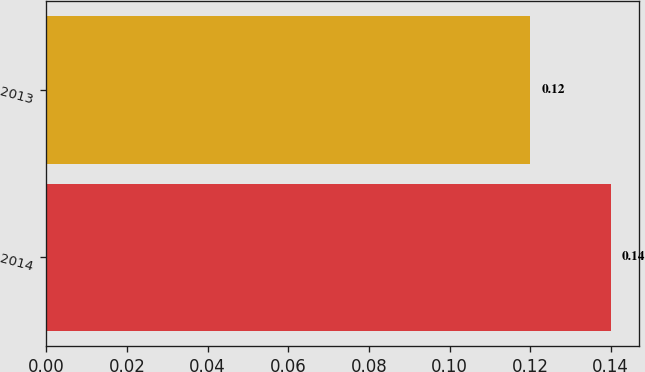Convert chart. <chart><loc_0><loc_0><loc_500><loc_500><bar_chart><fcel>2014<fcel>2013<nl><fcel>0.14<fcel>0.12<nl></chart> 